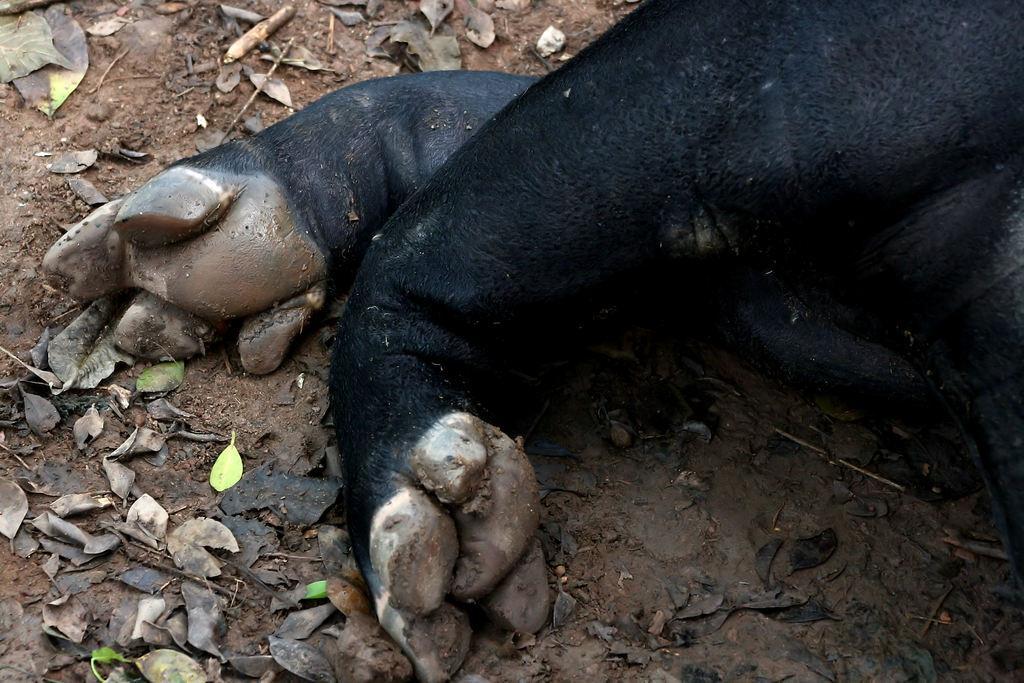Can you describe this image briefly? This picture shows an animal legs. They are black in color and we see leaves on the ground. 